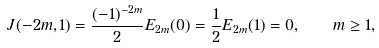Convert formula to latex. <formula><loc_0><loc_0><loc_500><loc_500>J ( - 2 m , 1 ) = \frac { ( - 1 ) ^ { - 2 m } } { 2 } E _ { 2 m } ( 0 ) = \frac { 1 } { 2 } E _ { 2 m } ( 1 ) = 0 , \quad m \geq 1 ,</formula> 